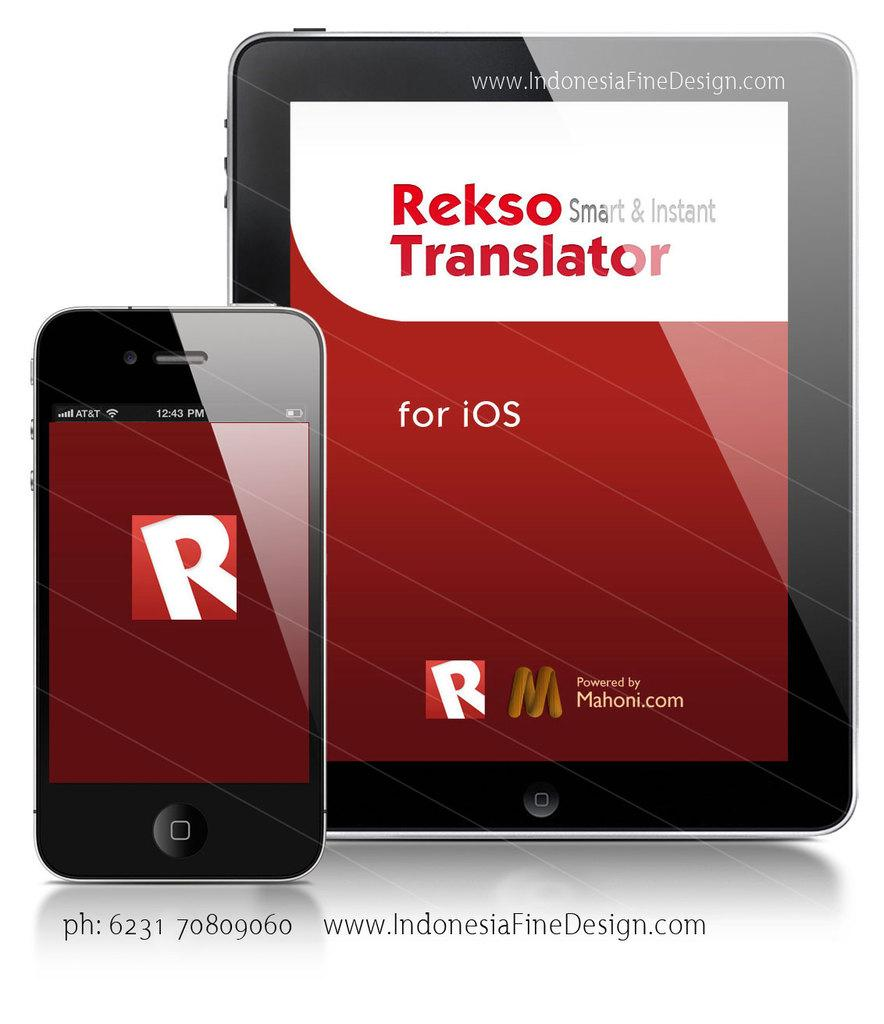<image>
Offer a succinct explanation of the picture presented. The phone sits beside the tablet with a translator app on it. 